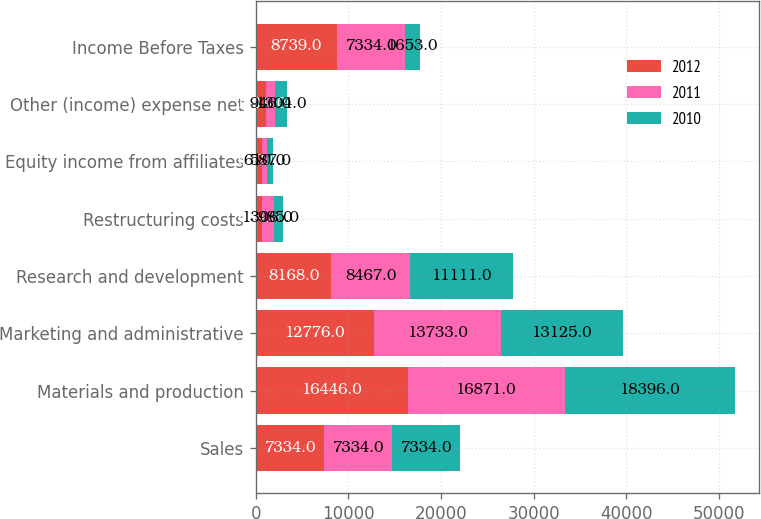Convert chart to OTSL. <chart><loc_0><loc_0><loc_500><loc_500><stacked_bar_chart><ecel><fcel>Sales<fcel>Materials and production<fcel>Marketing and administrative<fcel>Research and development<fcel>Restructuring costs<fcel>Equity income from affiliates<fcel>Other (income) expense net<fcel>Income Before Taxes<nl><fcel>2012<fcel>7334<fcel>16446<fcel>12776<fcel>8168<fcel>664<fcel>642<fcel>1116<fcel>8739<nl><fcel>2011<fcel>7334<fcel>16871<fcel>13733<fcel>8467<fcel>1306<fcel>610<fcel>946<fcel>7334<nl><fcel>2010<fcel>7334<fcel>18396<fcel>13125<fcel>11111<fcel>985<fcel>587<fcel>1304<fcel>1653<nl></chart> 